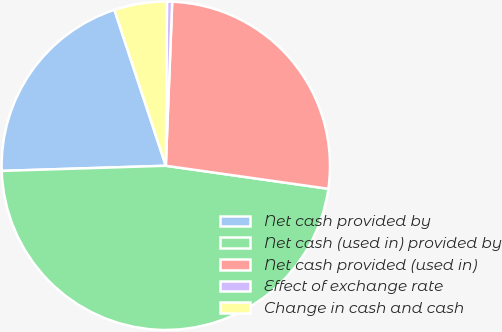Convert chart to OTSL. <chart><loc_0><loc_0><loc_500><loc_500><pie_chart><fcel>Net cash provided by<fcel>Net cash (used in) provided by<fcel>Net cash provided (used in)<fcel>Effect of exchange rate<fcel>Change in cash and cash<nl><fcel>20.43%<fcel>47.26%<fcel>26.62%<fcel>0.51%<fcel>5.18%<nl></chart> 